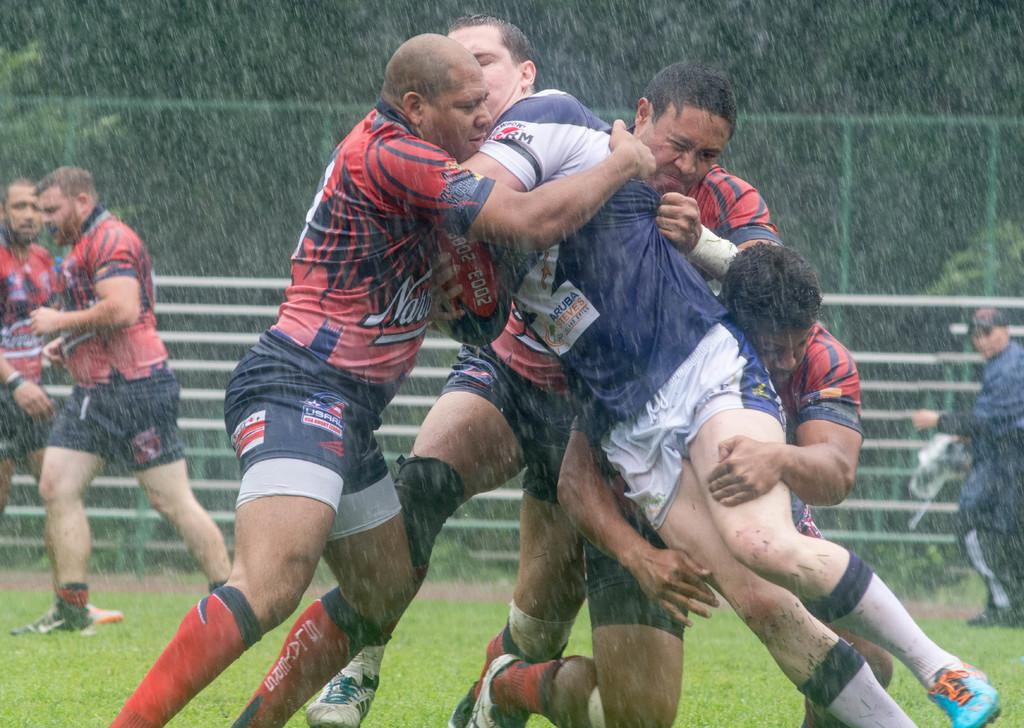What is happening in the image involving a group of people? The people in the image are playing a game. Where is the game being played? The game is being played on the ground. What can be seen in the background of the image? There is a metal fence and trees in the background of the image. What type of substance is the writer using to create their work in the image? There is no writer or substance present in the image; it features a group of people playing a game on the ground. 